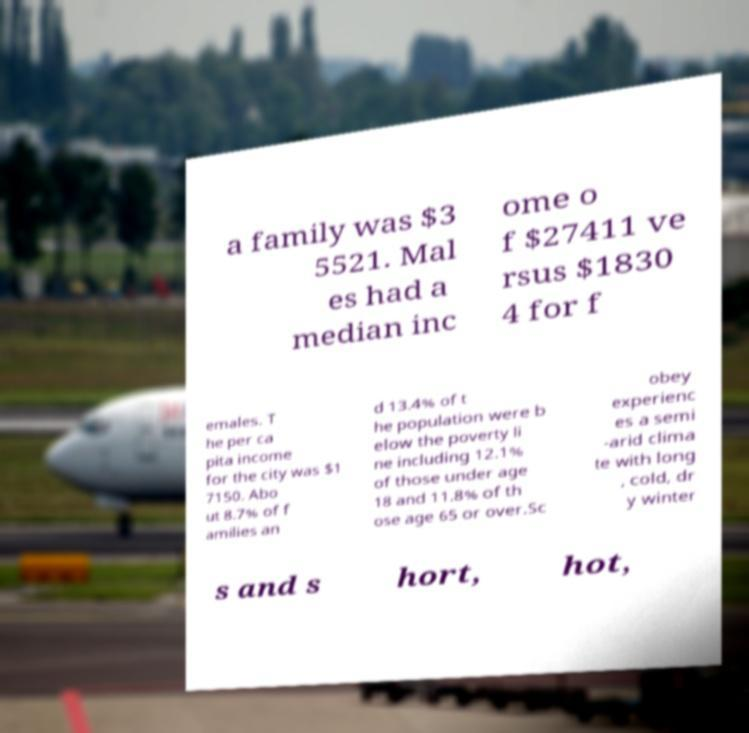There's text embedded in this image that I need extracted. Can you transcribe it verbatim? a family was $3 5521. Mal es had a median inc ome o f $27411 ve rsus $1830 4 for f emales. T he per ca pita income for the city was $1 7150. Abo ut 8.7% of f amilies an d 13.4% of t he population were b elow the poverty li ne including 12.1% of those under age 18 and 11.8% of th ose age 65 or over.Sc obey experienc es a semi -arid clima te with long , cold, dr y winter s and s hort, hot, 